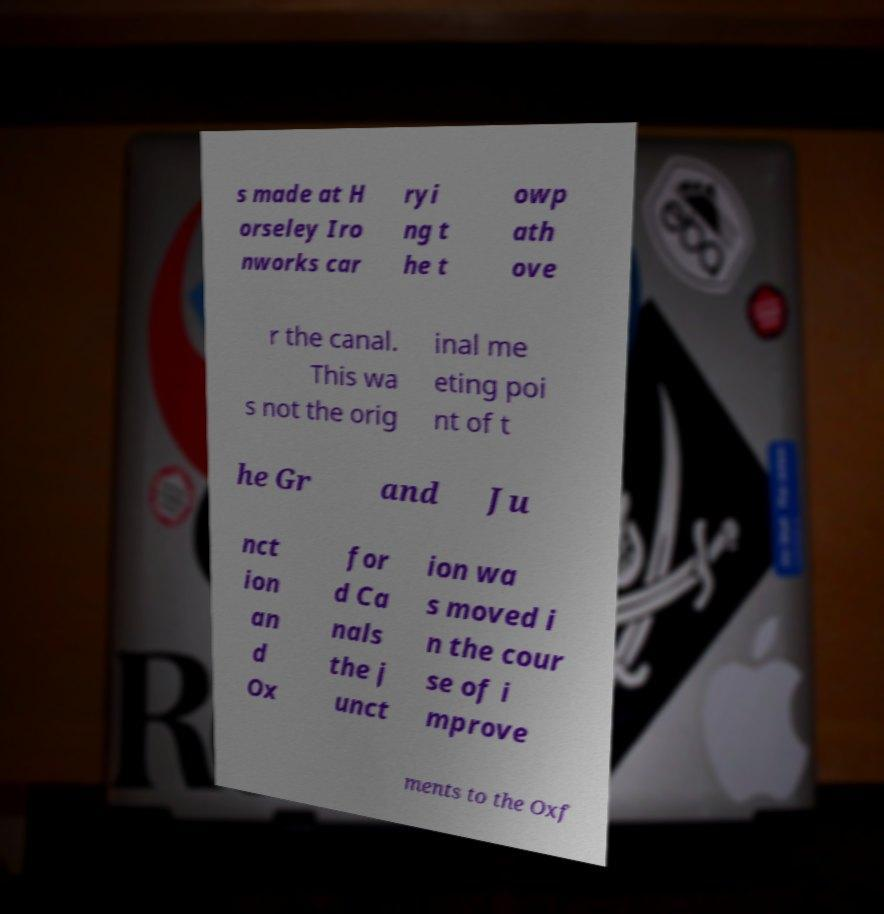For documentation purposes, I need the text within this image transcribed. Could you provide that? s made at H orseley Iro nworks car ryi ng t he t owp ath ove r the canal. This wa s not the orig inal me eting poi nt of t he Gr and Ju nct ion an d Ox for d Ca nals the j unct ion wa s moved i n the cour se of i mprove ments to the Oxf 